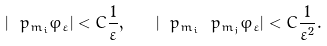<formula> <loc_0><loc_0><loc_500><loc_500>| \ p _ { m _ { i } } \varphi _ { \varepsilon } | < C \frac { 1 } { \varepsilon } , \quad | \ p _ { m _ { i } } \ p _ { m _ { j } } \varphi _ { \varepsilon } | < C \frac { 1 } { \varepsilon ^ { 2 } } .</formula> 